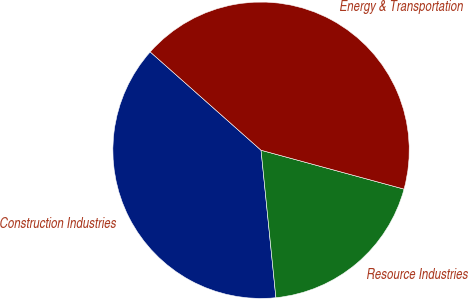<chart> <loc_0><loc_0><loc_500><loc_500><pie_chart><fcel>Construction Industries<fcel>Resource Industries<fcel>Energy & Transportation<nl><fcel>38.15%<fcel>19.18%<fcel>42.68%<nl></chart> 